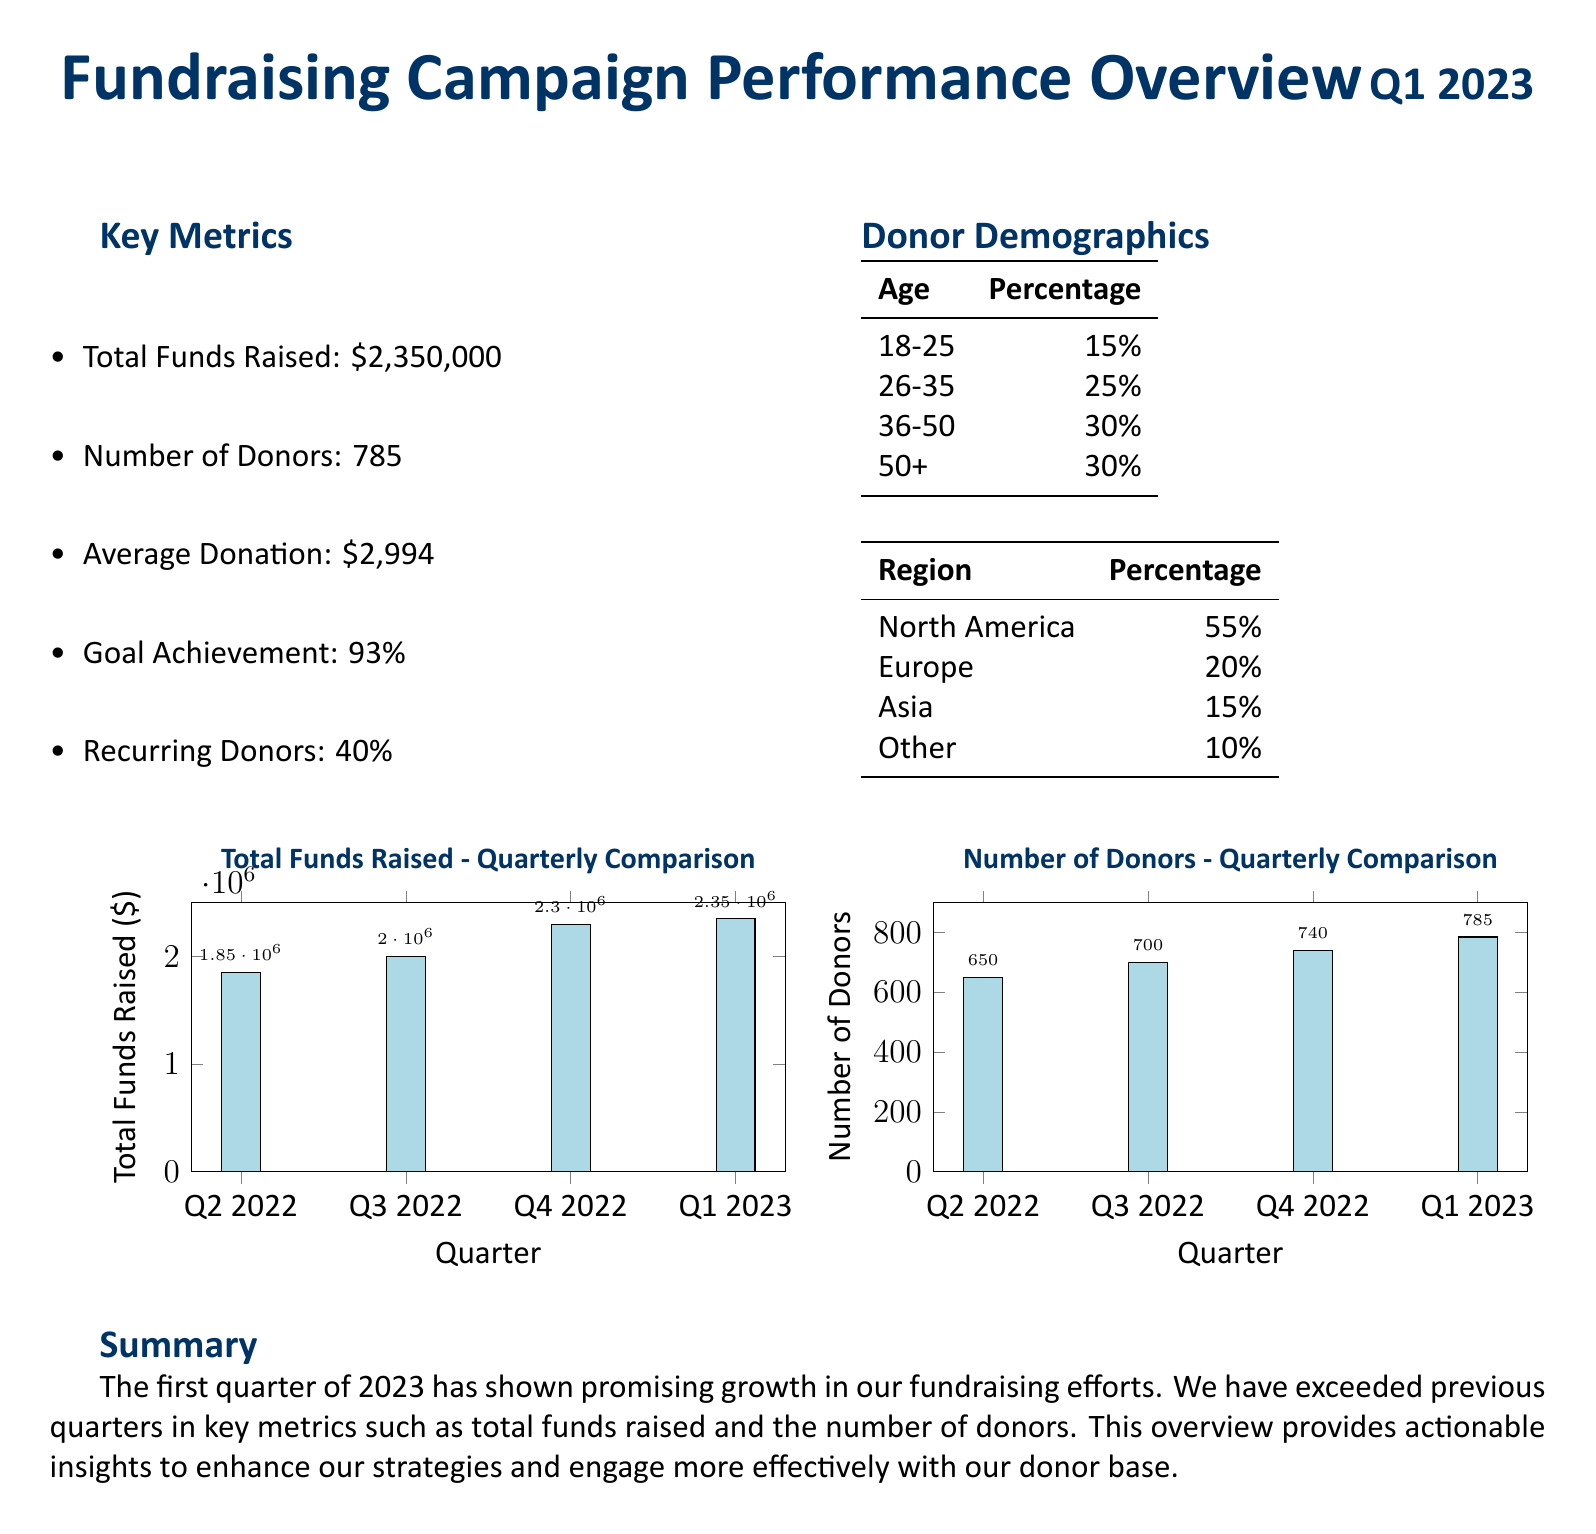What is the total funds raised in Q1 2023? The total funds raised is explicitly mentioned in the document as $2,350,000.
Answer: $2,350,000 What percentage of the goal was achieved in Q1 2023? The document states the goal achievement percentage for Q1 2023, which is 93%.
Answer: 93% How many donors were there in Q1 2023? The number of donors for Q1 2023 is provided in the document as 785.
Answer: 785 What is the average donation amount in Q1 2023? The average donation amount is clearly stated in the document as $2,994.
Answer: $2,994 Which age group had the highest percentage of donors? The donor demographics in the table indicate that the 36-50 age group has the highest percentage at 30%.
Answer: 36-50 What was the total funds raised in Q4 2022? By looking at the comparative visual for total funds raised, we see that Q4 2022 raised $2,300,000.
Answer: $2,300,000 Which region had the largest representation of donors? According to the donor demographics, North America is the region with the largest percentage, which is 55%.
Answer: North America How many recurring donors were there in Q1 2023? The document states that 40% of the donors were recurring, but does not specify a total number, only the percentage.
Answer: 40% What is the title of the document? The title of the document is explicitly presented at the top as "Fundraising Campaign Performance Overview."
Answer: Fundraising Campaign Performance Overview 